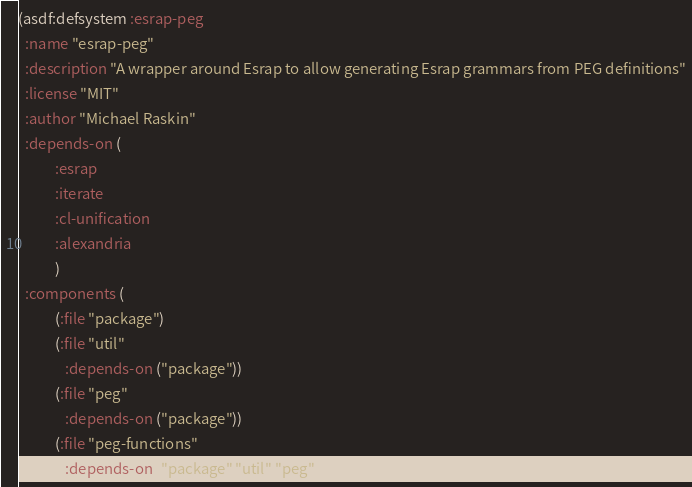Convert code to text. <code><loc_0><loc_0><loc_500><loc_500><_Lisp_>(asdf:defsystem :esrap-peg
  :name "esrap-peg"
  :description "A wrapper around Esrap to allow generating Esrap grammars from PEG definitions"
  :license "MIT"
  :author "Michael Raskin"
  :depends-on (
	       :esrap 
	       :iterate 
	       :cl-unification 
	       :alexandria
	       )
  :components (
	       (:file "package")
	       (:file "util"
		      :depends-on ("package"))
	       (:file "peg"
		      :depends-on ("package"))
	       (:file "peg-functions"
		      :depends-on ("package" "util" "peg"))</code> 